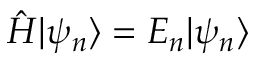<formula> <loc_0><loc_0><loc_500><loc_500>{ \hat { H } } | \psi _ { n } \rangle = E _ { n } | \psi _ { n } \rangle</formula> 